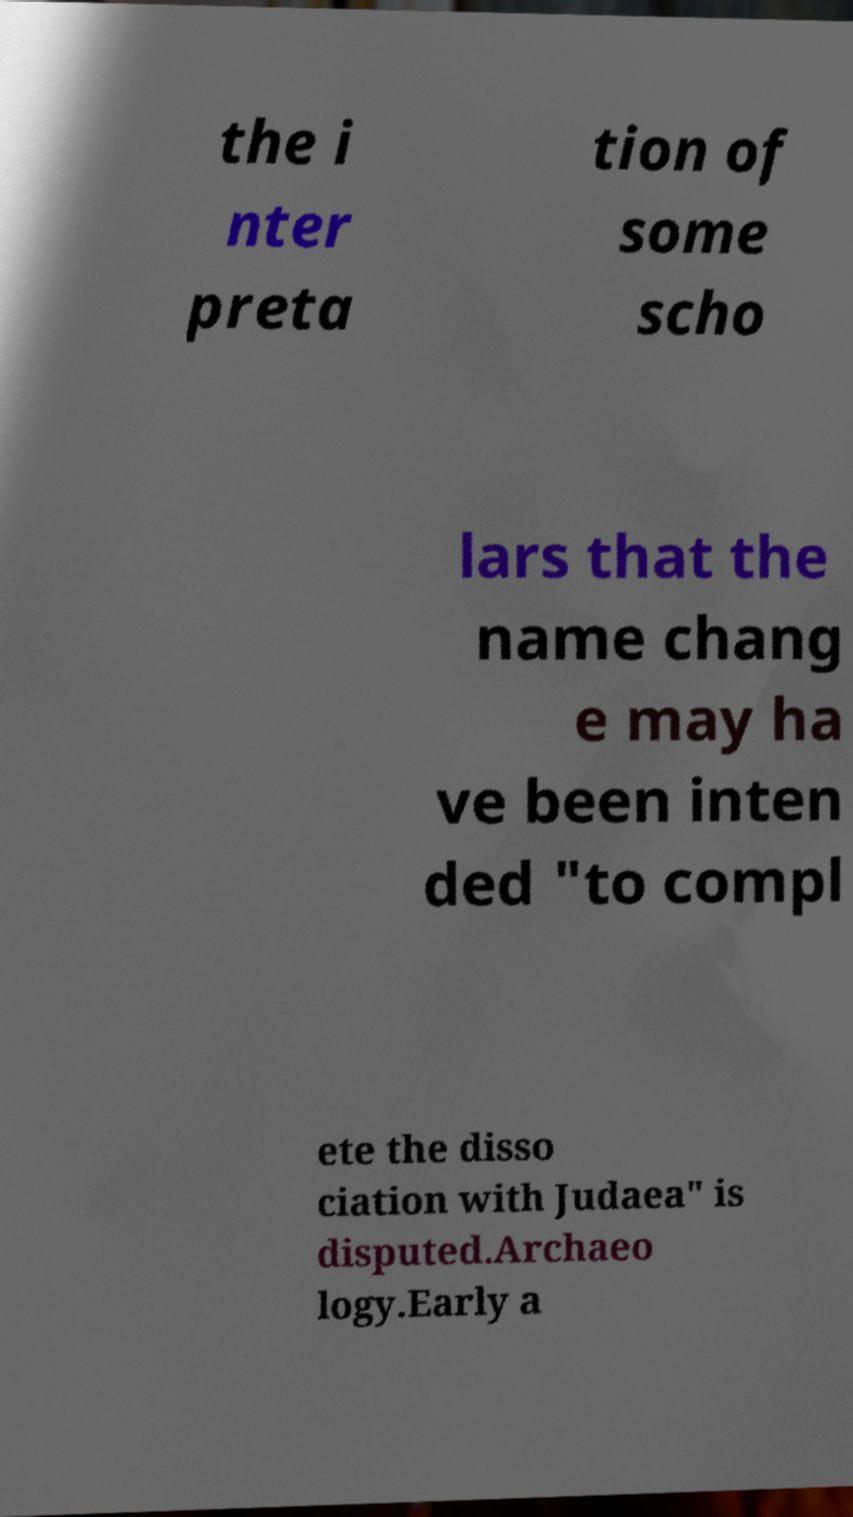For documentation purposes, I need the text within this image transcribed. Could you provide that? the i nter preta tion of some scho lars that the name chang e may ha ve been inten ded "to compl ete the disso ciation with Judaea" is disputed.Archaeo logy.Early a 